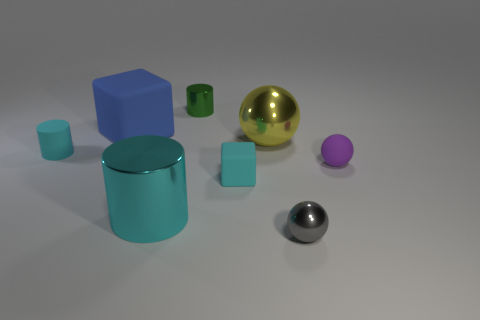Add 2 gray shiny things. How many objects exist? 10 Subtract all cylinders. How many objects are left? 5 Subtract 0 purple blocks. How many objects are left? 8 Subtract all matte things. Subtract all small metal spheres. How many objects are left? 3 Add 6 big cyan shiny cylinders. How many big cyan shiny cylinders are left? 7 Add 2 big metallic things. How many big metallic things exist? 4 